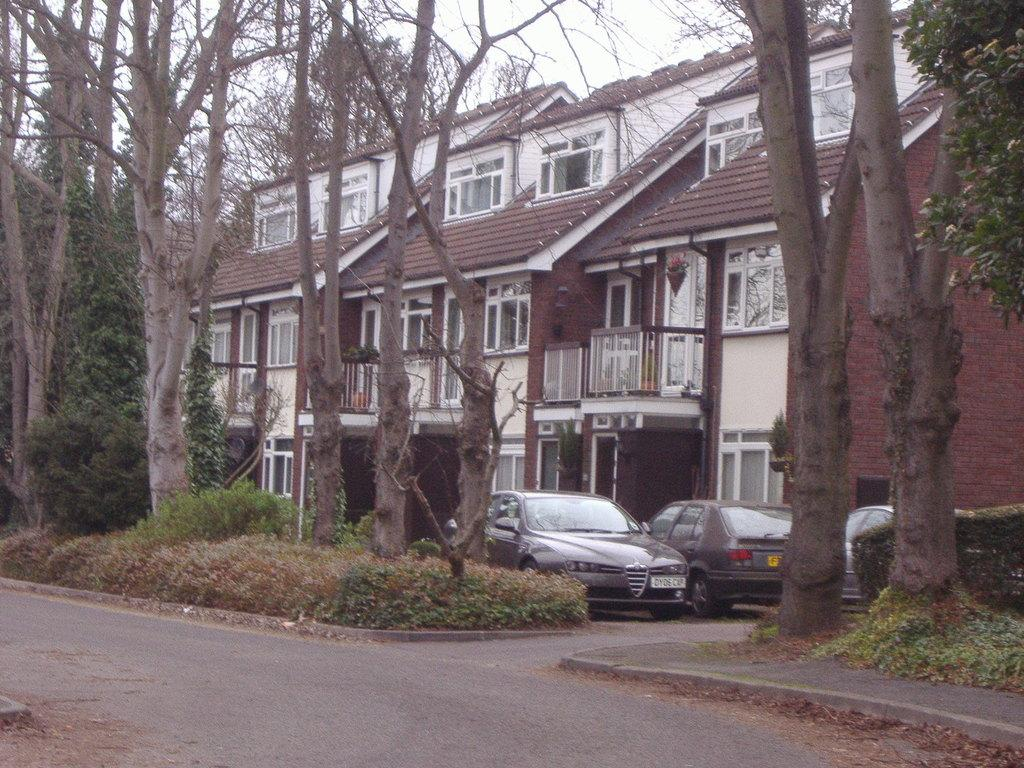What is located in the center of the image? There are buildings, cars, and trees in the center of the image. What is at the bottom of the image? There is a road and plants at the bottom of the image. What is visible at the top of the image? There is sky at the top of the image. Can you tell me how many points are being controlled by the rain in the image? There is no mention of points or rain in the image; it features buildings, cars, trees, a road, plants, and sky. 